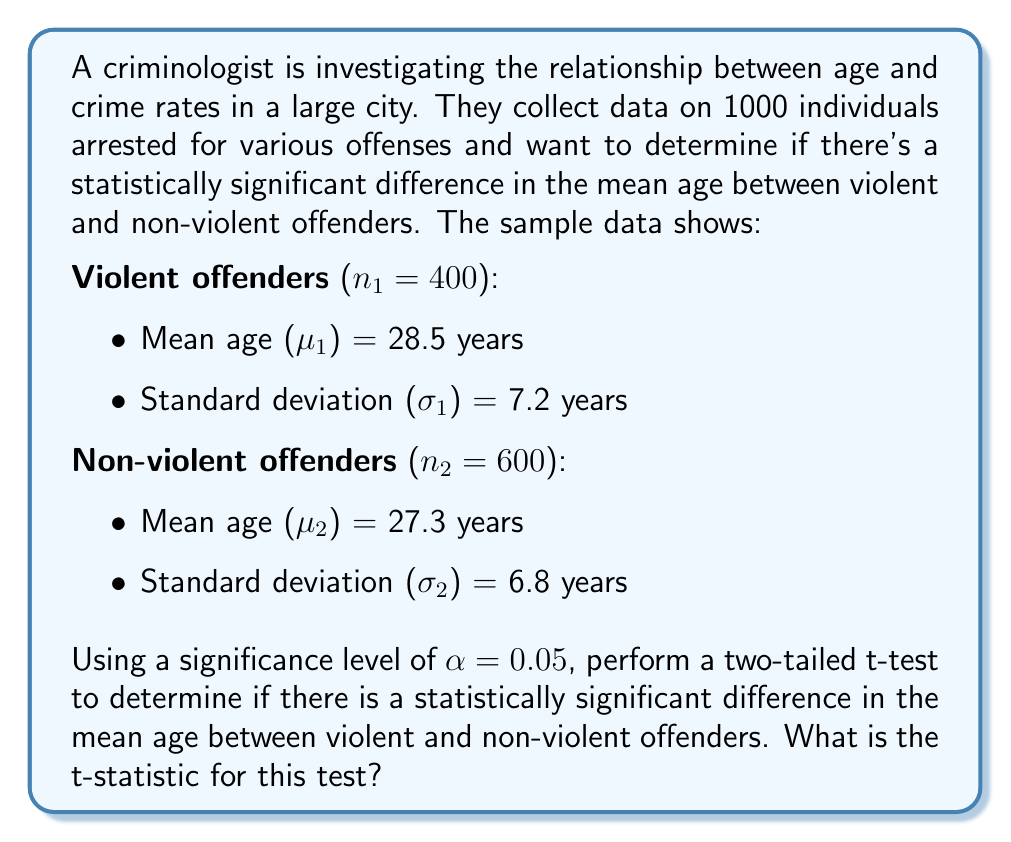Can you answer this question? To determine if there is a statistically significant difference in the mean age between violent and non-violent offenders, we need to perform a two-sample t-test. The steps are as follows:

1. State the null and alternative hypotheses:
   $H_0: \mu_1 - \mu_2 = 0$ (no difference in mean ages)
   $H_a: \mu_1 - \mu_2 \neq 0$ (there is a difference in mean ages)

2. Calculate the pooled standard error:
   $$SE = \sqrt{\frac{s_1^2}{n_1} + \frac{s_2^2}{n_2}}$$
   where $s_1$ and $s_2$ are the sample standard deviations, and $n_1$ and $n_2$ are the sample sizes.

   $$SE = \sqrt{\frac{7.2^2}{400} + \frac{6.8^2}{600}} = \sqrt{0.1296 + 0.0771} = \sqrt{0.2067} = 0.4547$$

3. Calculate the t-statistic:
   $$t = \frac{(\bar{x}_1 - \bar{x}_2) - (\mu_1 - \mu_2)}{SE}$$
   where $\bar{x}_1$ and $\bar{x}_2$ are the sample means, and $(\mu_1 - \mu_2) = 0$ under the null hypothesis.

   $$t = \frac{(28.5 - 27.3) - 0}{0.4547} = \frac{1.2}{0.4547} = 2.6392$$

4. The degrees of freedom for this test can be approximated using the Welch–Satterthwaite equation, but for large sample sizes like this, we can use the normal distribution as an approximation.

5. To determine statistical significance, we would compare this t-statistic to the critical value from a t-distribution with the appropriate degrees of freedom, or calculate the p-value. However, the question only asks for the t-statistic.
Answer: The t-statistic for this test is 2.6392. 